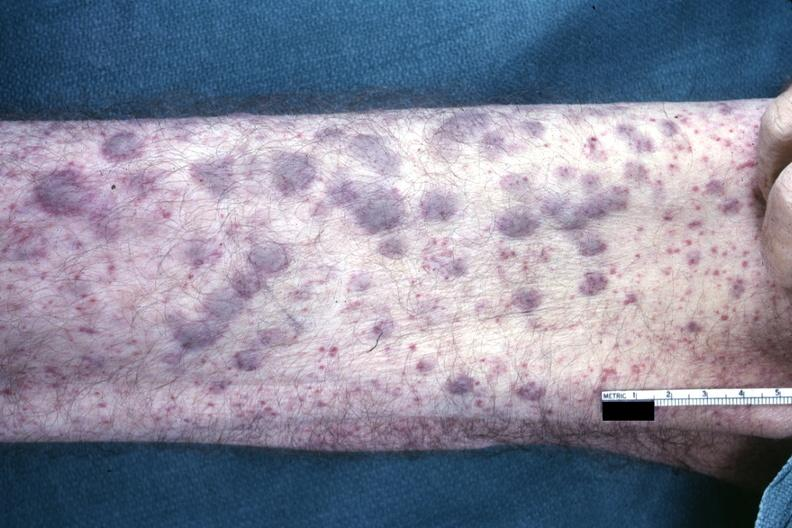what said to be infiltrates of aml?
Answer the question using a single word or phrase. Not good color photo showing elevated macular lesions 